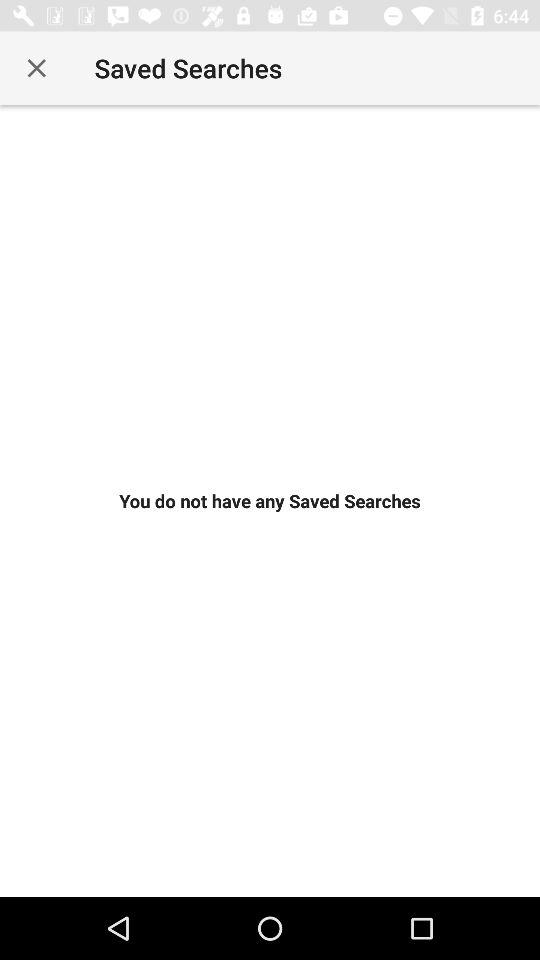Is there any saved search? There is no saved search. 